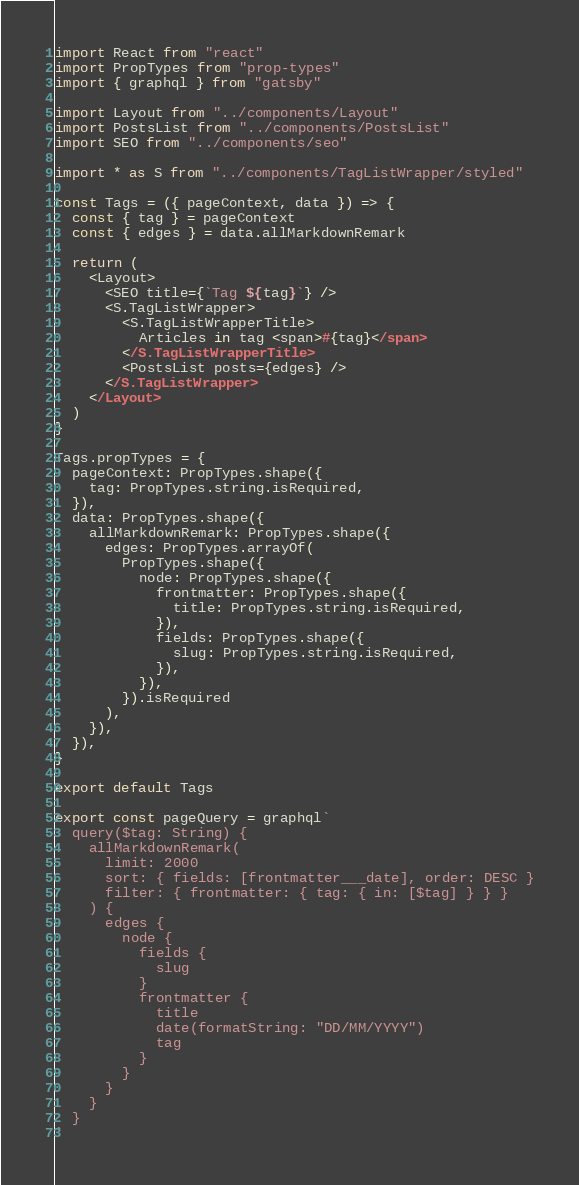Convert code to text. <code><loc_0><loc_0><loc_500><loc_500><_JavaScript_>import React from "react"
import PropTypes from "prop-types"
import { graphql } from "gatsby"

import Layout from "../components/Layout"
import PostsList from "../components/PostsList"
import SEO from "../components/seo"

import * as S from "../components/TagListWrapper/styled"

const Tags = ({ pageContext, data }) => {
  const { tag } = pageContext
  const { edges } = data.allMarkdownRemark

  return (
    <Layout>
      <SEO title={`Tag ${tag}`} />
      <S.TagListWrapper>
        <S.TagListWrapperTitle>
          Articles in tag <span>#{tag}</span>
        </S.TagListWrapperTitle>
        <PostsList posts={edges} />
      </S.TagListWrapper>
    </Layout>
  )
}

Tags.propTypes = {
  pageContext: PropTypes.shape({
    tag: PropTypes.string.isRequired,
  }),
  data: PropTypes.shape({
    allMarkdownRemark: PropTypes.shape({
      edges: PropTypes.arrayOf(
        PropTypes.shape({
          node: PropTypes.shape({
            frontmatter: PropTypes.shape({
              title: PropTypes.string.isRequired,
            }),
            fields: PropTypes.shape({
              slug: PropTypes.string.isRequired,
            }),
          }),
        }).isRequired
      ),
    }),
  }),
}

export default Tags

export const pageQuery = graphql`
  query($tag: String) {
    allMarkdownRemark(
      limit: 2000
      sort: { fields: [frontmatter___date], order: DESC }
      filter: { frontmatter: { tag: { in: [$tag] } } }
    ) {
      edges {
        node {
          fields {
            slug
          }
          frontmatter {
            title
            date(formatString: "DD/MM/YYYY")
            tag
          }
        }
      }
    }
  }
`
</code> 